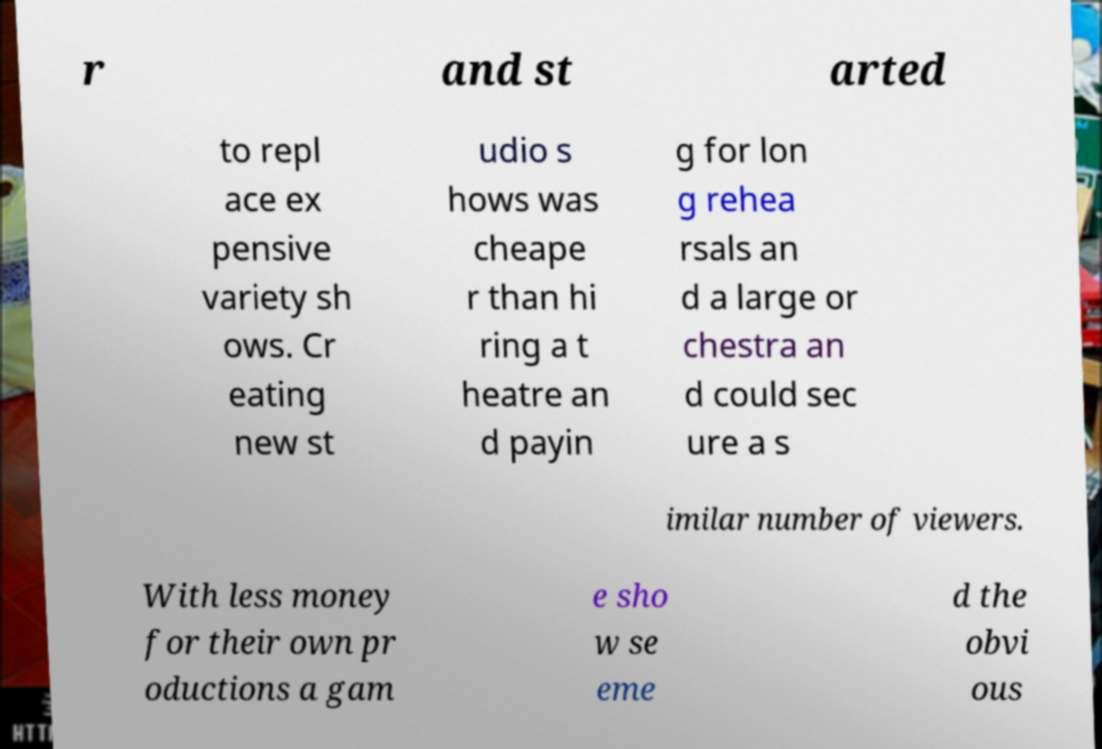Can you read and provide the text displayed in the image?This photo seems to have some interesting text. Can you extract and type it out for me? r and st arted to repl ace ex pensive variety sh ows. Cr eating new st udio s hows was cheape r than hi ring a t heatre an d payin g for lon g rehea rsals an d a large or chestra an d could sec ure a s imilar number of viewers. With less money for their own pr oductions a gam e sho w se eme d the obvi ous 